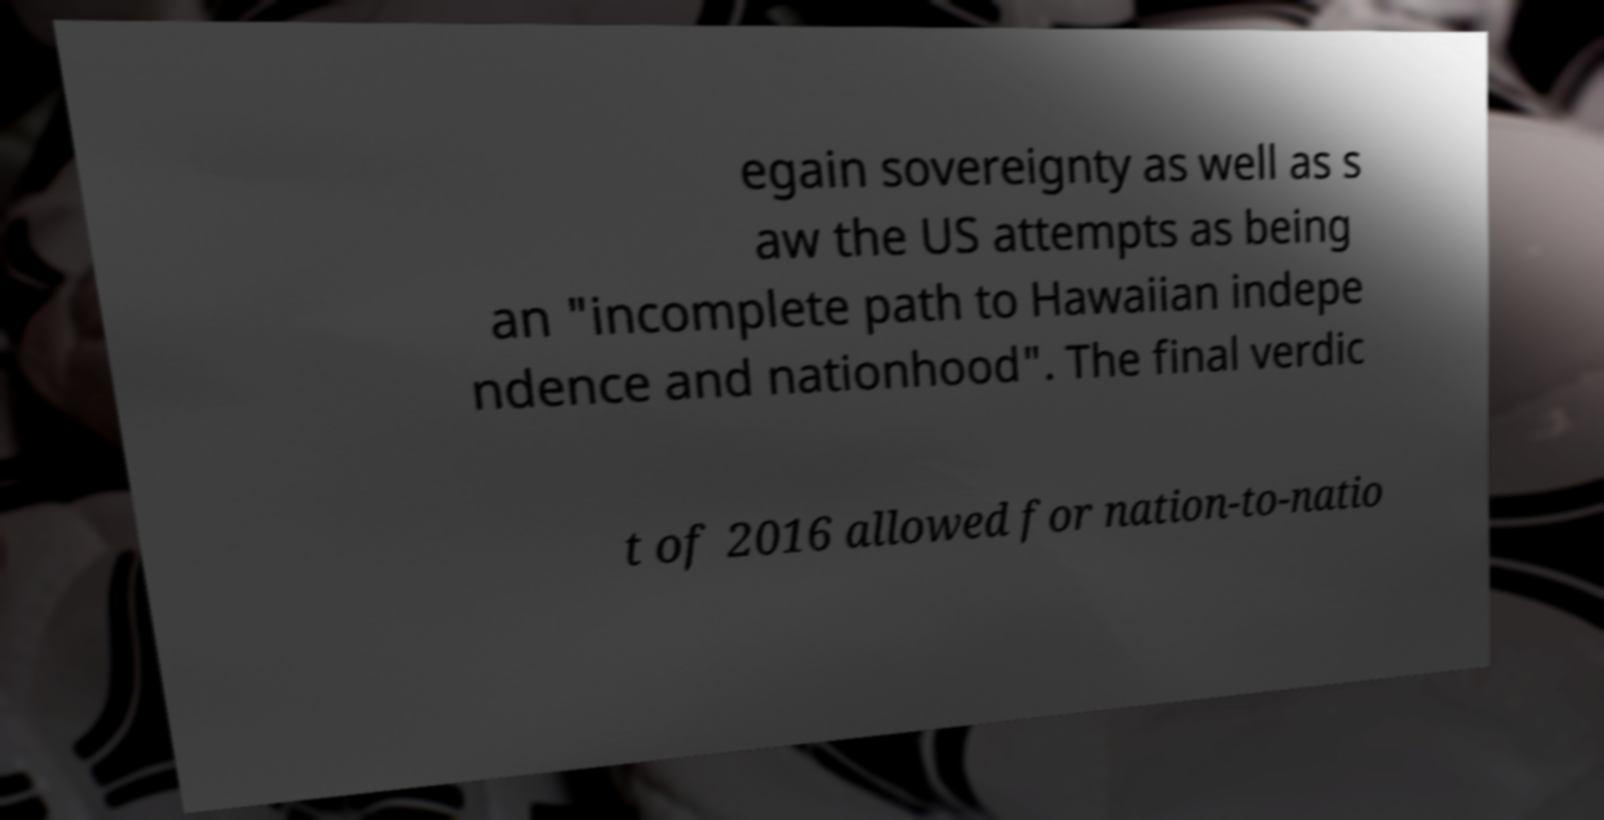Could you assist in decoding the text presented in this image and type it out clearly? egain sovereignty as well as s aw the US attempts as being an "incomplete path to Hawaiian indepe ndence and nationhood". The final verdic t of 2016 allowed for nation-to-natio 